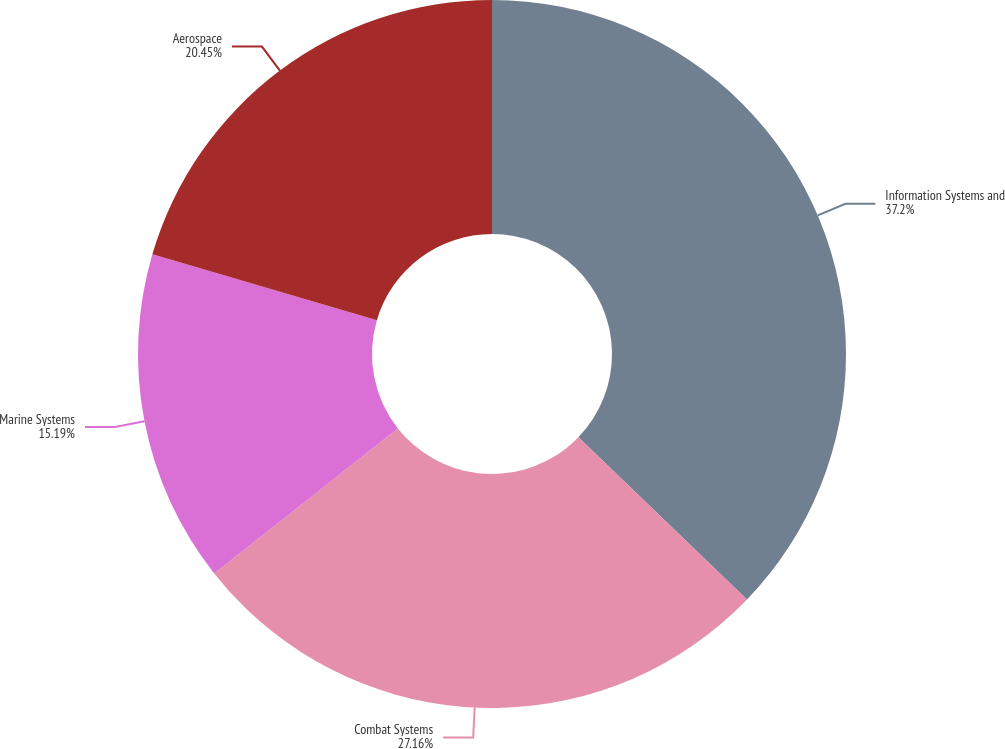Convert chart to OTSL. <chart><loc_0><loc_0><loc_500><loc_500><pie_chart><fcel>Information Systems and<fcel>Combat Systems<fcel>Marine Systems<fcel>Aerospace<nl><fcel>37.2%<fcel>27.16%<fcel>15.19%<fcel>20.45%<nl></chart> 